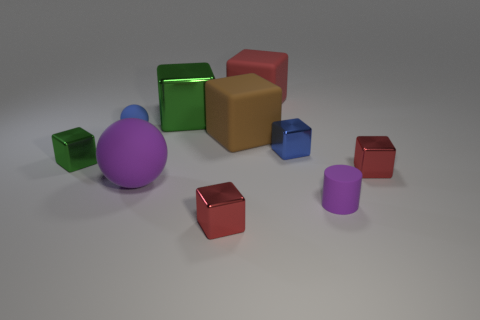Subtract all blue spheres. How many red cubes are left? 3 Subtract all red cubes. How many cubes are left? 4 Subtract all large brown rubber blocks. How many blocks are left? 6 Subtract all yellow blocks. Subtract all yellow cylinders. How many blocks are left? 7 Subtract all cylinders. How many objects are left? 9 Add 8 large green shiny objects. How many large green shiny objects are left? 9 Add 4 big blue metal blocks. How many big blue metal blocks exist? 4 Subtract 1 brown cubes. How many objects are left? 9 Subtract all large brown rubber objects. Subtract all big red matte cubes. How many objects are left? 8 